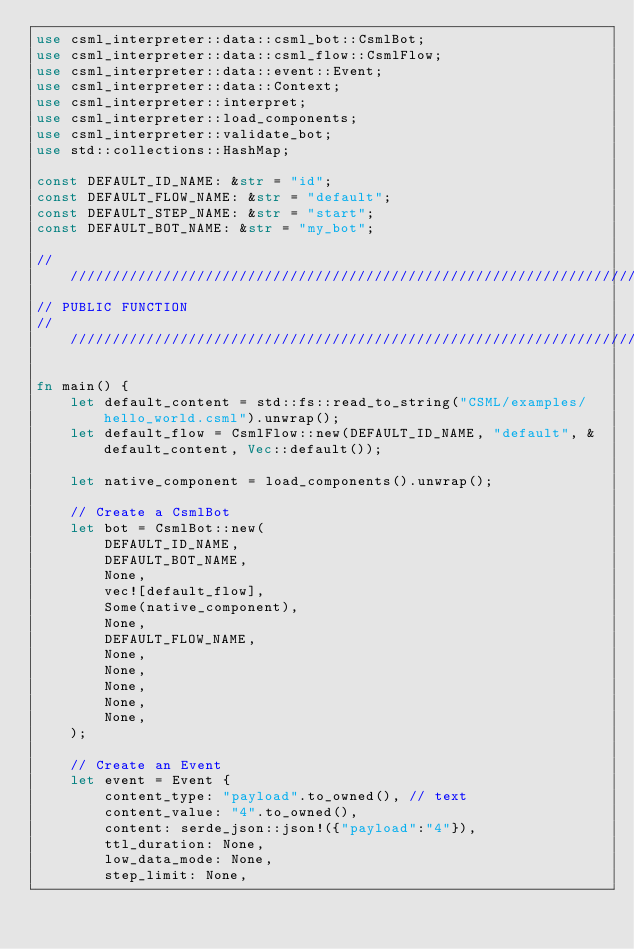Convert code to text. <code><loc_0><loc_0><loc_500><loc_500><_Rust_>use csml_interpreter::data::csml_bot::CsmlBot;
use csml_interpreter::data::csml_flow::CsmlFlow;
use csml_interpreter::data::event::Event;
use csml_interpreter::data::Context;
use csml_interpreter::interpret;
use csml_interpreter::load_components;
use csml_interpreter::validate_bot;
use std::collections::HashMap;

const DEFAULT_ID_NAME: &str = "id";
const DEFAULT_FLOW_NAME: &str = "default";
const DEFAULT_STEP_NAME: &str = "start";
const DEFAULT_BOT_NAME: &str = "my_bot";

////////////////////////////////////////////////////////////////////////////////
// PUBLIC FUNCTION
////////////////////////////////////////////////////////////////////////////////

fn main() {
    let default_content = std::fs::read_to_string("CSML/examples/hello_world.csml").unwrap();
    let default_flow = CsmlFlow::new(DEFAULT_ID_NAME, "default", &default_content, Vec::default());

    let native_component = load_components().unwrap();

    // Create a CsmlBot
    let bot = CsmlBot::new(
        DEFAULT_ID_NAME,
        DEFAULT_BOT_NAME,
        None,
        vec![default_flow],
        Some(native_component),
        None,
        DEFAULT_FLOW_NAME,
        None,
        None,
        None,
        None,
        None,
    );

    // Create an Event
    let event = Event {
        content_type: "payload".to_owned(), // text
        content_value: "4".to_owned(),
        content: serde_json::json!({"payload":"4"}),
        ttl_duration: None,
        low_data_mode: None,
        step_limit: None,</code> 